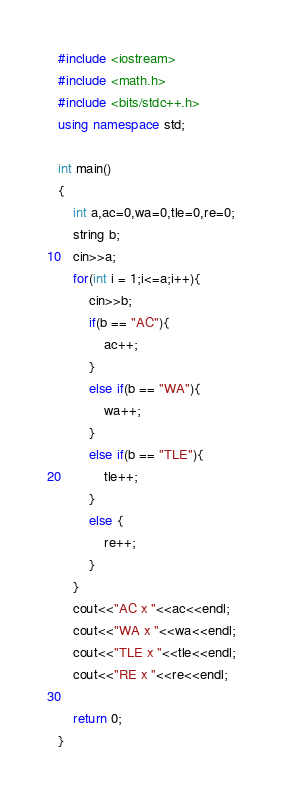Convert code to text. <code><loc_0><loc_0><loc_500><loc_500><_C++_>#include <iostream>
#include <math.h>
#include <bits/stdc++.h>
using namespace std;

int main()
{
    int a,ac=0,wa=0,tle=0,re=0;
    string b;
    cin>>a;
    for(int i = 1;i<=a;i++){
        cin>>b;
        if(b == "AC"){
            ac++;
        }
        else if(b == "WA"){
            wa++;
        }
        else if(b == "TLE"){
            tle++;
        }
        else {
            re++;
        }
    }
    cout<<"AC x "<<ac<<endl;
    cout<<"WA x "<<wa<<endl;
    cout<<"TLE x "<<tle<<endl;
    cout<<"RE x "<<re<<endl;

    return 0;
}</code> 